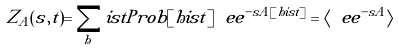<formula> <loc_0><loc_0><loc_500><loc_500>Z _ { A } ( s , t ) = \sum _ { h } i s t P r o b [ h i s t ] \ e e ^ { - s A [ h i s t ] } = \langle \ e e ^ { - s A } \rangle</formula> 